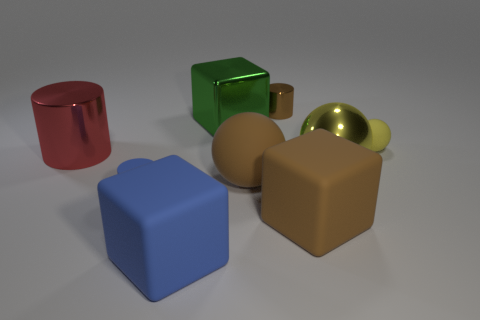Subtract all matte blocks. How many blocks are left? 1 Subtract all cylinders. How many objects are left? 6 Subtract all brown cylinders. How many cylinders are left? 2 Subtract 1 cylinders. How many cylinders are left? 2 Subtract all gray blocks. Subtract all cyan balls. How many blocks are left? 3 Subtract all cyan cylinders. How many yellow blocks are left? 0 Subtract all red metal cylinders. Subtract all green metallic blocks. How many objects are left? 7 Add 9 small metal things. How many small metal things are left? 10 Add 5 small cyan cylinders. How many small cyan cylinders exist? 5 Add 1 large brown rubber objects. How many objects exist? 10 